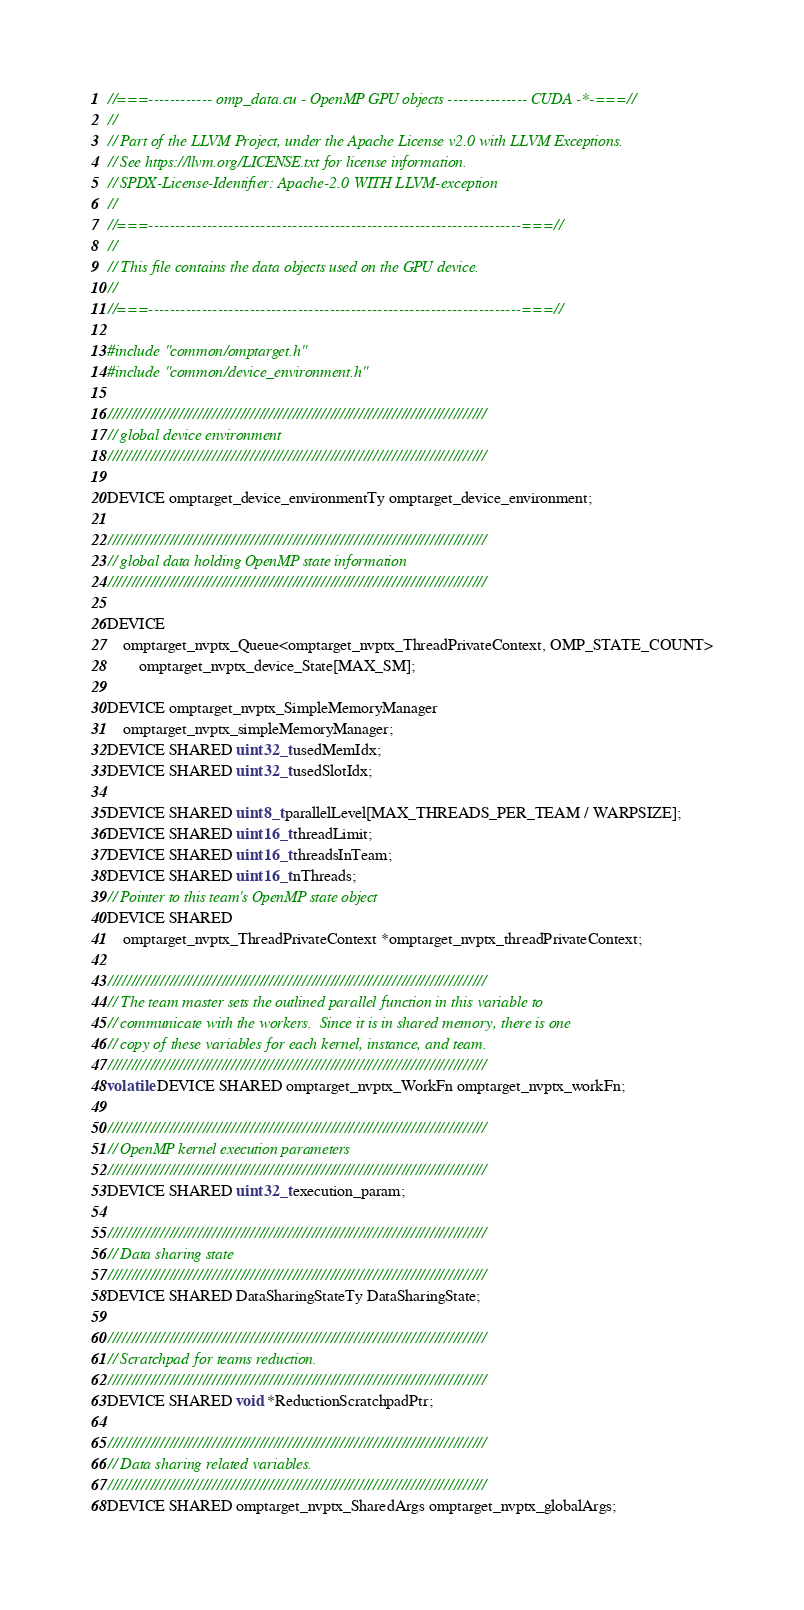<code> <loc_0><loc_0><loc_500><loc_500><_Cuda_>//===------------ omp_data.cu - OpenMP GPU objects --------------- CUDA -*-===//
//
// Part of the LLVM Project, under the Apache License v2.0 with LLVM Exceptions.
// See https://llvm.org/LICENSE.txt for license information.
// SPDX-License-Identifier: Apache-2.0 WITH LLVM-exception
//
//===----------------------------------------------------------------------===//
//
// This file contains the data objects used on the GPU device.
//
//===----------------------------------------------------------------------===//

#include "common/omptarget.h"
#include "common/device_environment.h"

////////////////////////////////////////////////////////////////////////////////
// global device environment
////////////////////////////////////////////////////////////////////////////////

DEVICE omptarget_device_environmentTy omptarget_device_environment;

////////////////////////////////////////////////////////////////////////////////
// global data holding OpenMP state information
////////////////////////////////////////////////////////////////////////////////

DEVICE
    omptarget_nvptx_Queue<omptarget_nvptx_ThreadPrivateContext, OMP_STATE_COUNT>
        omptarget_nvptx_device_State[MAX_SM];

DEVICE omptarget_nvptx_SimpleMemoryManager
    omptarget_nvptx_simpleMemoryManager;
DEVICE SHARED uint32_t usedMemIdx;
DEVICE SHARED uint32_t usedSlotIdx;

DEVICE SHARED uint8_t parallelLevel[MAX_THREADS_PER_TEAM / WARPSIZE];
DEVICE SHARED uint16_t threadLimit;
DEVICE SHARED uint16_t threadsInTeam;
DEVICE SHARED uint16_t nThreads;
// Pointer to this team's OpenMP state object
DEVICE SHARED
    omptarget_nvptx_ThreadPrivateContext *omptarget_nvptx_threadPrivateContext;

////////////////////////////////////////////////////////////////////////////////
// The team master sets the outlined parallel function in this variable to
// communicate with the workers.  Since it is in shared memory, there is one
// copy of these variables for each kernel, instance, and team.
////////////////////////////////////////////////////////////////////////////////
volatile DEVICE SHARED omptarget_nvptx_WorkFn omptarget_nvptx_workFn;

////////////////////////////////////////////////////////////////////////////////
// OpenMP kernel execution parameters
////////////////////////////////////////////////////////////////////////////////
DEVICE SHARED uint32_t execution_param;

////////////////////////////////////////////////////////////////////////////////
// Data sharing state
////////////////////////////////////////////////////////////////////////////////
DEVICE SHARED DataSharingStateTy DataSharingState;

////////////////////////////////////////////////////////////////////////////////
// Scratchpad for teams reduction.
////////////////////////////////////////////////////////////////////////////////
DEVICE SHARED void *ReductionScratchpadPtr;

////////////////////////////////////////////////////////////////////////////////
// Data sharing related variables.
////////////////////////////////////////////////////////////////////////////////
DEVICE SHARED omptarget_nvptx_SharedArgs omptarget_nvptx_globalArgs;
</code> 